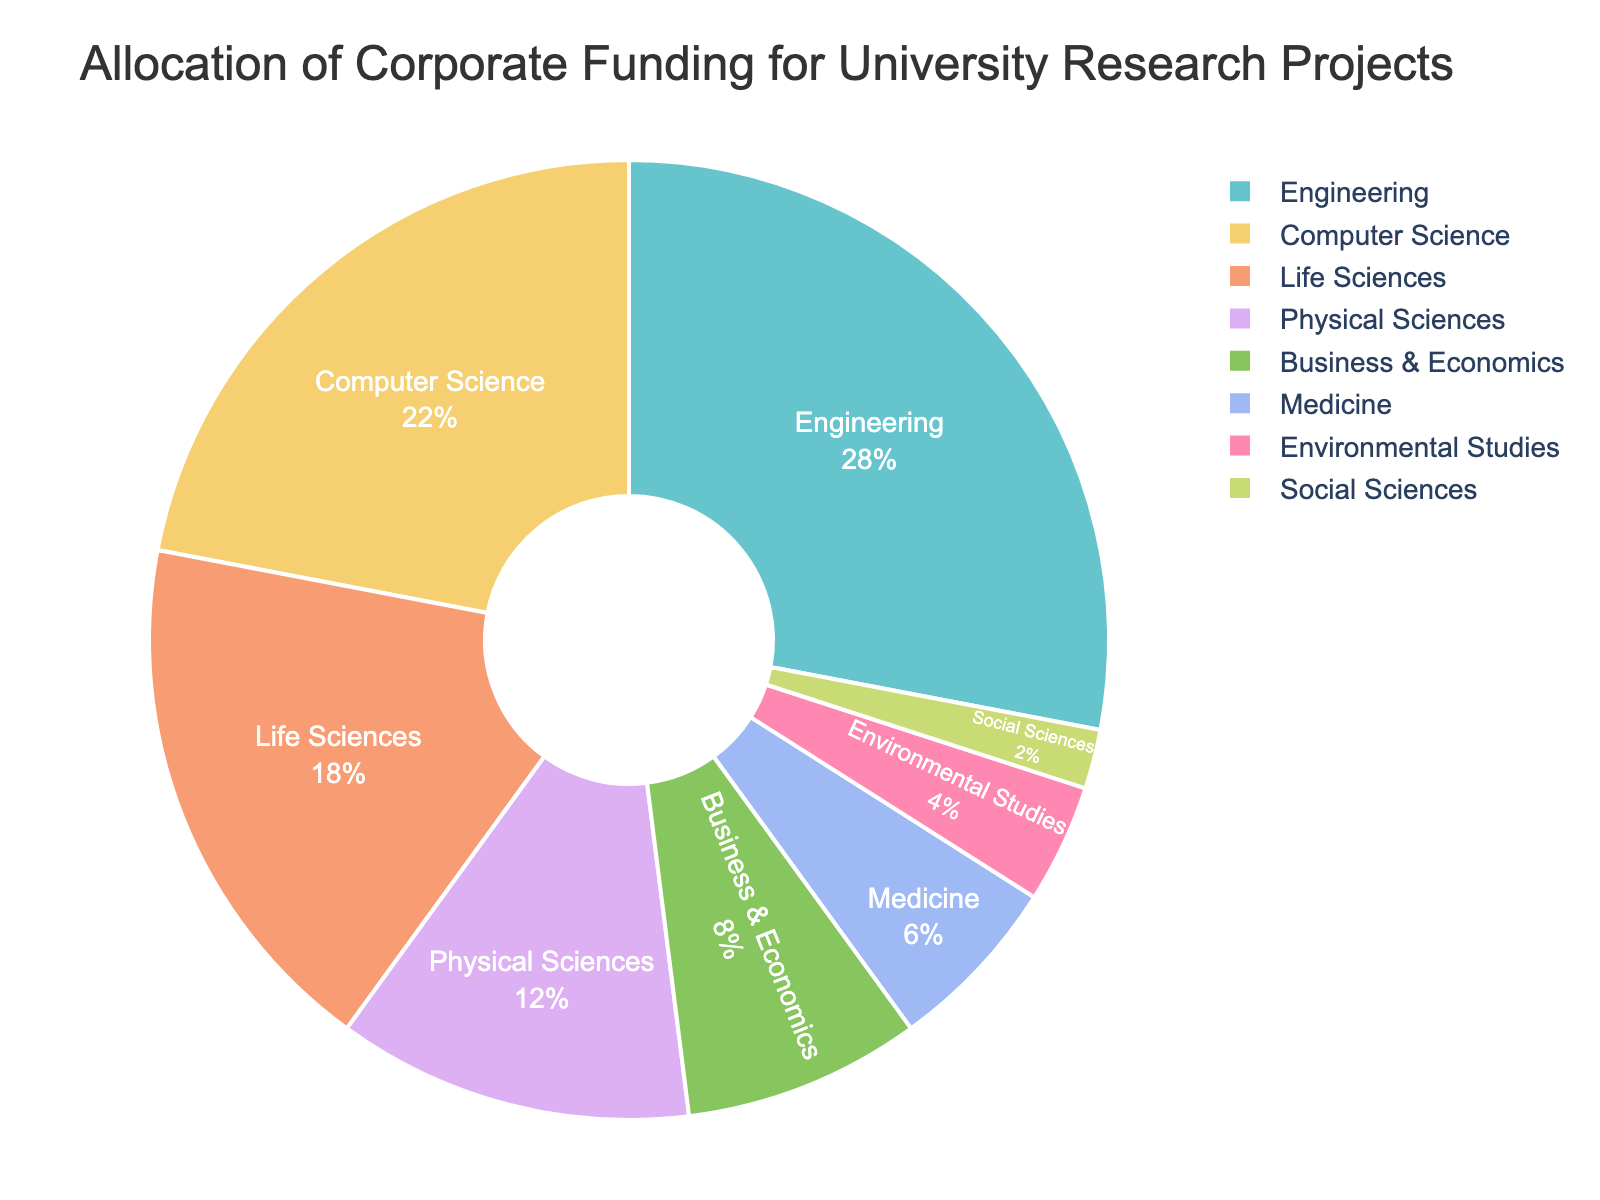what is the field with the highest percentage of corporate funding? To identify the field with the highest percentage, look at the largest segment in the pie chart. The largest segment represents Engineering with 28%.
Answer: Engineering which fields receive more than 20% of the corporate funding? The pie chart shows that the fields greater than 20% are those slices occupying more than one-fifth of the chart. Engineering (28%) and Computer Science (22%) fit this criterion.
Answer: Engineering, Computer Science what is the combined funding percentage for Life Sciences, Physical Sciences, and Medicine? Sum the percentages for Life Sciences (18%), Physical Sciences (12%), and Medicine (6%). Thus, 18 + 12 + 6 = 36%.
Answer: 36% how does the funding for Environmental Studies compare to Social Sciences? Compare the percentages directly: Environmental Studies has 4% while Social Sciences has 2%. Environmental Studies has more funding.
Answer: Environmental Studies has more what fields receive less funding than Business & Economics? Compare the percentages to Business & Economics which has 8%. Fields with less than 8% are Medicine (6%), Environmental Studies (4%), and Social Sciences (2%).
Answer: Medicine, Environmental Studies, Social Sciences which field is allocated 6% of the corporate funding? Look at the slice labeled with 6%. The field is Medicine.
Answer: Medicine what percentage of funding is allocated to fields outside Engineering and Computer Science? Add all other percentages: Life Sciences (18%) + Physical Sciences (12%) + Business & Economics (8%) + Medicine (6%) + Environmental Studies (4%) + Social Sciences (2%). Total is 50%.
Answer: 50% which field's funding is closest to 5%? Compare the percentages to 5%: Environmental Studies has 4%, which is closest to 5%.
Answer: Environmental Studies 